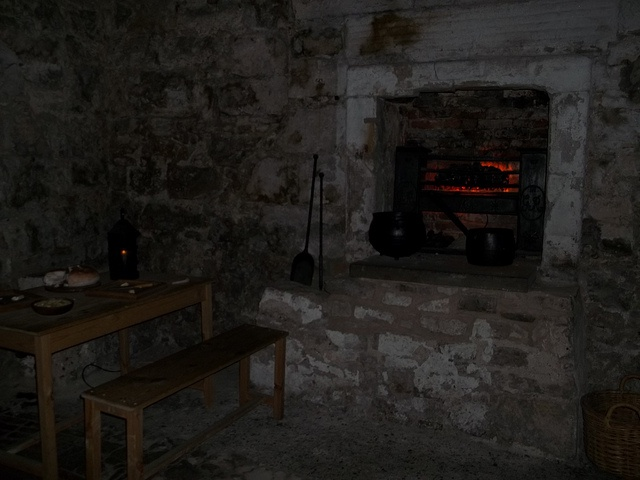Describe the objects in this image and their specific colors. I can see bench in black tones, dining table in black and gray tones, bowl in black tones, sandwich in black tones, and sandwich in black tones in this image. 